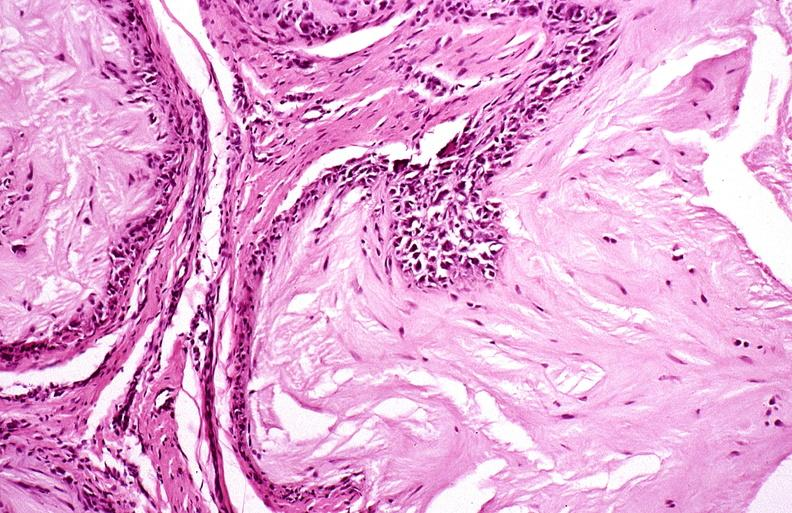s joints present?
Answer the question using a single word or phrase. Yes 